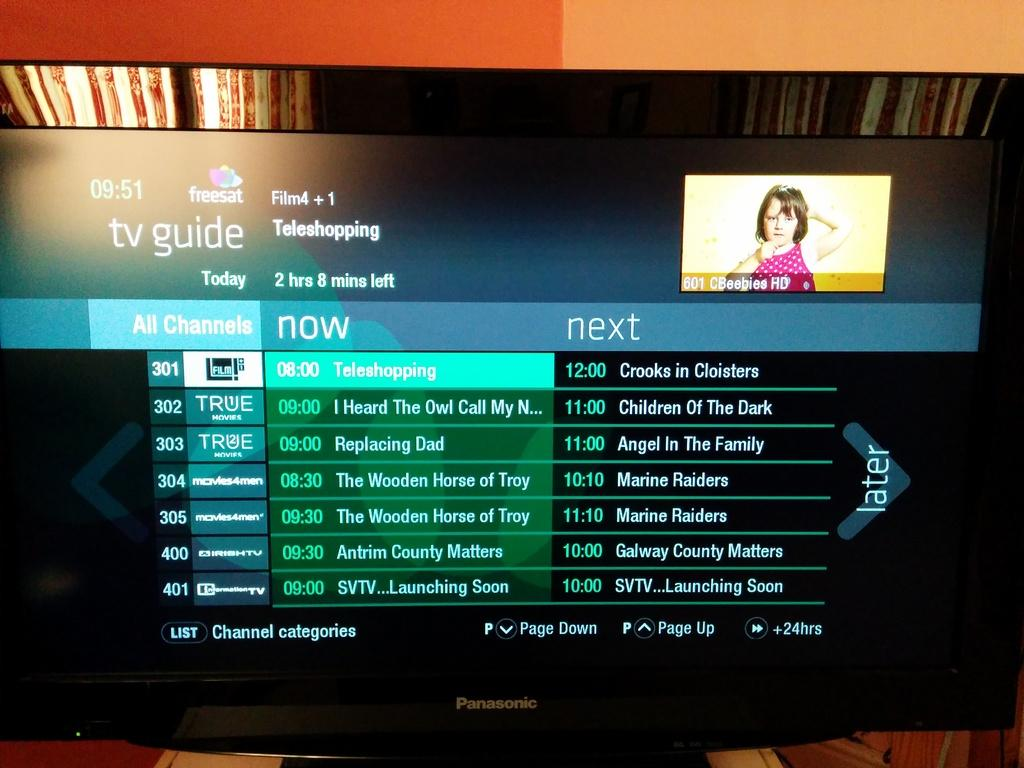<image>
Provide a brief description of the given image. the word next that is on a screen 